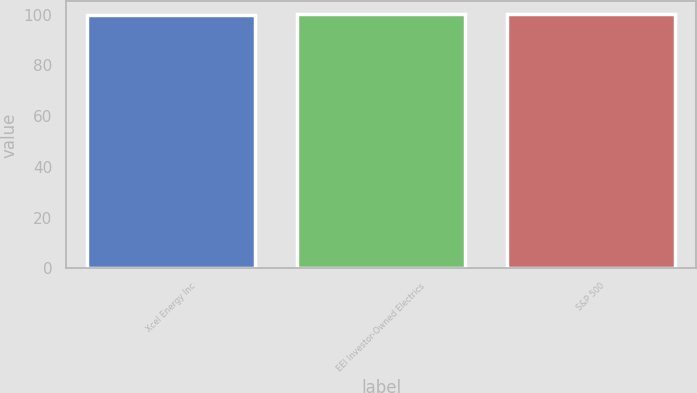<chart> <loc_0><loc_0><loc_500><loc_500><bar_chart><fcel>Xcel Energy Inc<fcel>EEI Investor-Owned Electrics<fcel>S&P 500<nl><fcel>100<fcel>100.1<fcel>100.2<nl></chart> 